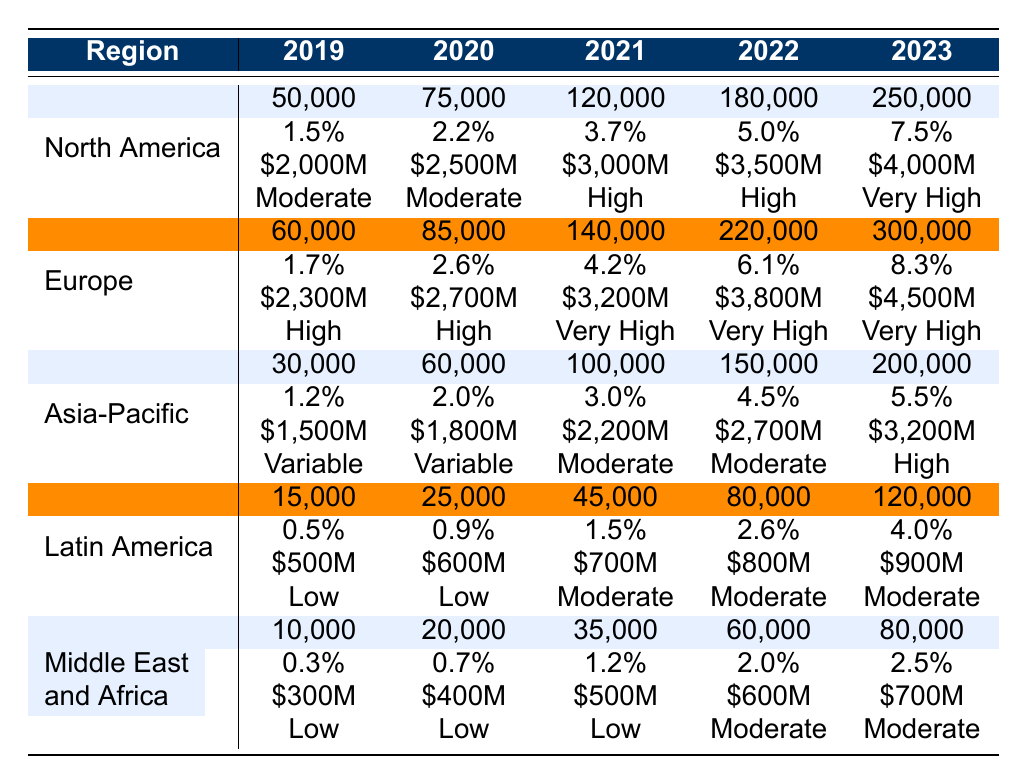What is the market share percentage for North America in 2022? The table shows that North America's market share percentage in 2022 is 5.0%.
Answer: 5.0% How many vehicles were adopted in Europe in 2021? From the table, Europe adopted 140,000 vehicles in 2021.
Answer: 140,000 What was the total investment in autonomous vehicles in Asia-Pacific over the last five years? Adding the investments from 2019 to 2023 gives us $1,500M + $1,800M + $2,200M + $2,700M + $3,200M = $11,400M.
Answer: $11,400M Which region had the highest number of vehicles adopted in 2023? The table indicates that Europe led with 300,000 vehicles adopted in 2023, more than any other region.
Answer: Europe What was the percentage increase in vehicle adoption in Latin America from 2022 to 2023? The number of vehicles adopted in Latin America increased from 80,000 in 2022 to 120,000 in 2023. The percentage increase is ((120,000 - 80,000) / 80,000) * 100 = 50%.
Answer: 50% Did the market share percentage in the Middle East and Africa exceed 2% in 2022? The table shows the market share percentage for the Middle East and Africa in 2022 was 2.0%, which is not greater than 2%.
Answer: No What is the average number of vehicles adopted in North America from 2019 to 2023? Adding the number of vehicles adopted each year gives us 50,000 + 75,000 + 120,000 + 180,000 + 250,000 = 675,000. Dividing by 5 years gives us an average of 675,000 / 5 = 135,000.
Answer: 135,000 Which region had the lowest regulatory support in 2019? The table lists the regulatory support for the Middle East and Africa as "Low" in 2019, which is the lowest compared to other regions.
Answer: Middle East and Africa What is the total number of vehicles adopted across all regions in 2020? Summing up the vehicles adopted in each region for 2020 gives 75,000 (North America) + 85,000 (Europe) + 60,000 (Asia-Pacific) + 25,000 (Latin America) + 20,000 (Middle East and Africa) = 265,000.
Answer: 265,000 How much did North America invest in autonomous vehicles cumulatively from 2019 to 2023? Adding North America's investments gives $2,000M + $2,500M + $3,000M + $3,500M + $4,000M = $15,000M cumulatively.
Answer: $15,000M 